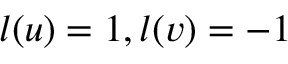Convert formula to latex. <formula><loc_0><loc_0><loc_500><loc_500>l ( u ) = 1 , l ( v ) = - 1</formula> 